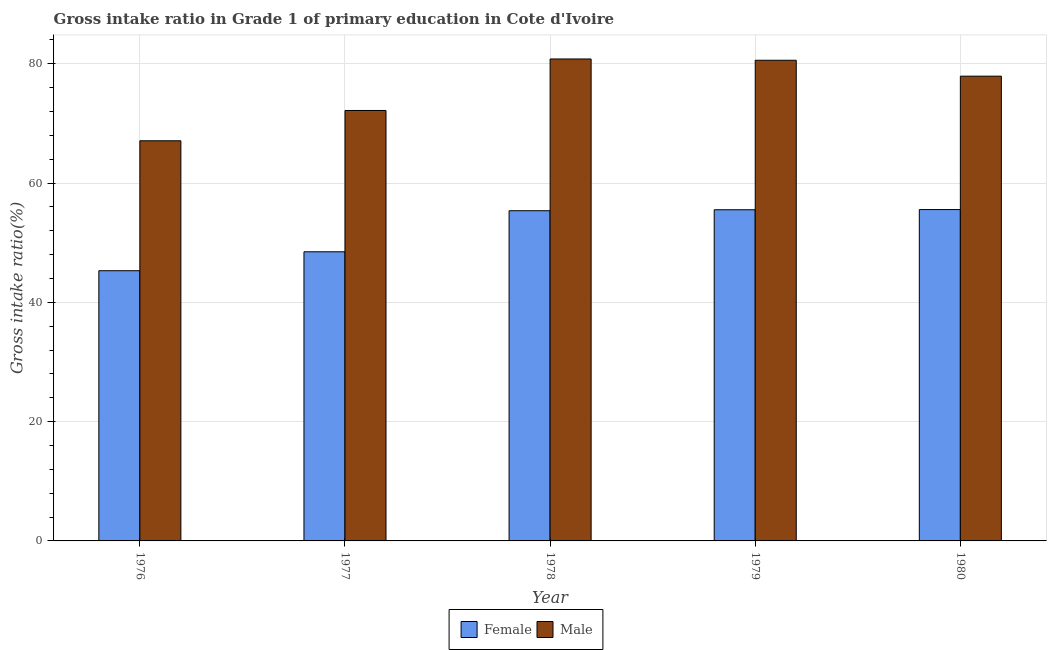Are the number of bars per tick equal to the number of legend labels?
Make the answer very short. Yes. Are the number of bars on each tick of the X-axis equal?
Your response must be concise. Yes. How many bars are there on the 4th tick from the right?
Offer a terse response. 2. What is the label of the 1st group of bars from the left?
Your answer should be very brief. 1976. In how many cases, is the number of bars for a given year not equal to the number of legend labels?
Your answer should be compact. 0. What is the gross intake ratio(male) in 1976?
Your answer should be very brief. 67.09. Across all years, what is the maximum gross intake ratio(female)?
Provide a short and direct response. 55.55. Across all years, what is the minimum gross intake ratio(male)?
Provide a succinct answer. 67.09. In which year was the gross intake ratio(male) maximum?
Your answer should be compact. 1978. In which year was the gross intake ratio(female) minimum?
Your response must be concise. 1976. What is the total gross intake ratio(male) in the graph?
Your answer should be compact. 378.56. What is the difference between the gross intake ratio(male) in 1976 and that in 1979?
Provide a succinct answer. -13.5. What is the difference between the gross intake ratio(female) in 1976 and the gross intake ratio(male) in 1977?
Your response must be concise. -3.17. What is the average gross intake ratio(male) per year?
Offer a terse response. 75.71. In the year 1976, what is the difference between the gross intake ratio(male) and gross intake ratio(female)?
Your response must be concise. 0. In how many years, is the gross intake ratio(female) greater than 36 %?
Give a very brief answer. 5. What is the ratio of the gross intake ratio(female) in 1977 to that in 1978?
Your response must be concise. 0.88. What is the difference between the highest and the second highest gross intake ratio(male)?
Ensure brevity in your answer.  0.21. What is the difference between the highest and the lowest gross intake ratio(female)?
Offer a very short reply. 10.25. In how many years, is the gross intake ratio(male) greater than the average gross intake ratio(male) taken over all years?
Your answer should be very brief. 3. Is the sum of the gross intake ratio(female) in 1976 and 1979 greater than the maximum gross intake ratio(male) across all years?
Offer a terse response. Yes. What does the 2nd bar from the right in 1977 represents?
Give a very brief answer. Female. Are all the bars in the graph horizontal?
Provide a succinct answer. No. How many years are there in the graph?
Provide a short and direct response. 5. What is the difference between two consecutive major ticks on the Y-axis?
Ensure brevity in your answer.  20. Does the graph contain any zero values?
Your response must be concise. No. Does the graph contain grids?
Keep it short and to the point. Yes. How many legend labels are there?
Make the answer very short. 2. How are the legend labels stacked?
Your answer should be very brief. Horizontal. What is the title of the graph?
Make the answer very short. Gross intake ratio in Grade 1 of primary education in Cote d'Ivoire. What is the label or title of the Y-axis?
Give a very brief answer. Gross intake ratio(%). What is the Gross intake ratio(%) in Female in 1976?
Provide a succinct answer. 45.3. What is the Gross intake ratio(%) of Male in 1976?
Provide a short and direct response. 67.09. What is the Gross intake ratio(%) of Female in 1977?
Give a very brief answer. 48.47. What is the Gross intake ratio(%) in Male in 1977?
Give a very brief answer. 72.17. What is the Gross intake ratio(%) of Female in 1978?
Your answer should be compact. 55.36. What is the Gross intake ratio(%) of Male in 1978?
Keep it short and to the point. 80.8. What is the Gross intake ratio(%) of Female in 1979?
Your response must be concise. 55.52. What is the Gross intake ratio(%) in Male in 1979?
Your answer should be compact. 80.59. What is the Gross intake ratio(%) of Female in 1980?
Your response must be concise. 55.55. What is the Gross intake ratio(%) in Male in 1980?
Offer a terse response. 77.92. Across all years, what is the maximum Gross intake ratio(%) of Female?
Provide a short and direct response. 55.55. Across all years, what is the maximum Gross intake ratio(%) of Male?
Your response must be concise. 80.8. Across all years, what is the minimum Gross intake ratio(%) of Female?
Ensure brevity in your answer.  45.3. Across all years, what is the minimum Gross intake ratio(%) in Male?
Provide a succinct answer. 67.09. What is the total Gross intake ratio(%) of Female in the graph?
Keep it short and to the point. 260.21. What is the total Gross intake ratio(%) of Male in the graph?
Provide a short and direct response. 378.56. What is the difference between the Gross intake ratio(%) in Female in 1976 and that in 1977?
Keep it short and to the point. -3.17. What is the difference between the Gross intake ratio(%) in Male in 1976 and that in 1977?
Your response must be concise. -5.08. What is the difference between the Gross intake ratio(%) in Female in 1976 and that in 1978?
Your answer should be compact. -10.06. What is the difference between the Gross intake ratio(%) of Male in 1976 and that in 1978?
Your answer should be very brief. -13.71. What is the difference between the Gross intake ratio(%) in Female in 1976 and that in 1979?
Offer a very short reply. -10.22. What is the difference between the Gross intake ratio(%) in Male in 1976 and that in 1979?
Provide a succinct answer. -13.5. What is the difference between the Gross intake ratio(%) of Female in 1976 and that in 1980?
Your answer should be compact. -10.25. What is the difference between the Gross intake ratio(%) in Male in 1976 and that in 1980?
Provide a succinct answer. -10.83. What is the difference between the Gross intake ratio(%) in Female in 1977 and that in 1978?
Your response must be concise. -6.89. What is the difference between the Gross intake ratio(%) in Male in 1977 and that in 1978?
Make the answer very short. -8.64. What is the difference between the Gross intake ratio(%) in Female in 1977 and that in 1979?
Ensure brevity in your answer.  -7.05. What is the difference between the Gross intake ratio(%) in Male in 1977 and that in 1979?
Your response must be concise. -8.42. What is the difference between the Gross intake ratio(%) of Female in 1977 and that in 1980?
Give a very brief answer. -7.08. What is the difference between the Gross intake ratio(%) in Male in 1977 and that in 1980?
Give a very brief answer. -5.75. What is the difference between the Gross intake ratio(%) of Female in 1978 and that in 1979?
Provide a short and direct response. -0.16. What is the difference between the Gross intake ratio(%) in Male in 1978 and that in 1979?
Offer a terse response. 0.21. What is the difference between the Gross intake ratio(%) in Female in 1978 and that in 1980?
Make the answer very short. -0.19. What is the difference between the Gross intake ratio(%) of Male in 1978 and that in 1980?
Keep it short and to the point. 2.88. What is the difference between the Gross intake ratio(%) in Female in 1979 and that in 1980?
Make the answer very short. -0.03. What is the difference between the Gross intake ratio(%) in Male in 1979 and that in 1980?
Make the answer very short. 2.67. What is the difference between the Gross intake ratio(%) of Female in 1976 and the Gross intake ratio(%) of Male in 1977?
Your answer should be very brief. -26.87. What is the difference between the Gross intake ratio(%) of Female in 1976 and the Gross intake ratio(%) of Male in 1978?
Keep it short and to the point. -35.5. What is the difference between the Gross intake ratio(%) in Female in 1976 and the Gross intake ratio(%) in Male in 1979?
Provide a succinct answer. -35.29. What is the difference between the Gross intake ratio(%) of Female in 1976 and the Gross intake ratio(%) of Male in 1980?
Offer a terse response. -32.62. What is the difference between the Gross intake ratio(%) of Female in 1977 and the Gross intake ratio(%) of Male in 1978?
Offer a very short reply. -32.33. What is the difference between the Gross intake ratio(%) of Female in 1977 and the Gross intake ratio(%) of Male in 1979?
Offer a terse response. -32.11. What is the difference between the Gross intake ratio(%) of Female in 1977 and the Gross intake ratio(%) of Male in 1980?
Ensure brevity in your answer.  -29.45. What is the difference between the Gross intake ratio(%) of Female in 1978 and the Gross intake ratio(%) of Male in 1979?
Offer a very short reply. -25.23. What is the difference between the Gross intake ratio(%) in Female in 1978 and the Gross intake ratio(%) in Male in 1980?
Your answer should be very brief. -22.56. What is the difference between the Gross intake ratio(%) in Female in 1979 and the Gross intake ratio(%) in Male in 1980?
Provide a succinct answer. -22.4. What is the average Gross intake ratio(%) of Female per year?
Your answer should be very brief. 52.04. What is the average Gross intake ratio(%) of Male per year?
Offer a very short reply. 75.71. In the year 1976, what is the difference between the Gross intake ratio(%) of Female and Gross intake ratio(%) of Male?
Keep it short and to the point. -21.79. In the year 1977, what is the difference between the Gross intake ratio(%) of Female and Gross intake ratio(%) of Male?
Provide a short and direct response. -23.69. In the year 1978, what is the difference between the Gross intake ratio(%) of Female and Gross intake ratio(%) of Male?
Offer a terse response. -25.44. In the year 1979, what is the difference between the Gross intake ratio(%) of Female and Gross intake ratio(%) of Male?
Make the answer very short. -25.06. In the year 1980, what is the difference between the Gross intake ratio(%) in Female and Gross intake ratio(%) in Male?
Your answer should be compact. -22.37. What is the ratio of the Gross intake ratio(%) of Female in 1976 to that in 1977?
Provide a succinct answer. 0.93. What is the ratio of the Gross intake ratio(%) of Male in 1976 to that in 1977?
Give a very brief answer. 0.93. What is the ratio of the Gross intake ratio(%) of Female in 1976 to that in 1978?
Your response must be concise. 0.82. What is the ratio of the Gross intake ratio(%) in Male in 1976 to that in 1978?
Your answer should be very brief. 0.83. What is the ratio of the Gross intake ratio(%) in Female in 1976 to that in 1979?
Make the answer very short. 0.82. What is the ratio of the Gross intake ratio(%) in Male in 1976 to that in 1979?
Provide a succinct answer. 0.83. What is the ratio of the Gross intake ratio(%) of Female in 1976 to that in 1980?
Offer a terse response. 0.82. What is the ratio of the Gross intake ratio(%) in Male in 1976 to that in 1980?
Give a very brief answer. 0.86. What is the ratio of the Gross intake ratio(%) in Female in 1977 to that in 1978?
Give a very brief answer. 0.88. What is the ratio of the Gross intake ratio(%) of Male in 1977 to that in 1978?
Give a very brief answer. 0.89. What is the ratio of the Gross intake ratio(%) of Female in 1977 to that in 1979?
Your response must be concise. 0.87. What is the ratio of the Gross intake ratio(%) in Male in 1977 to that in 1979?
Make the answer very short. 0.9. What is the ratio of the Gross intake ratio(%) in Female in 1977 to that in 1980?
Ensure brevity in your answer.  0.87. What is the ratio of the Gross intake ratio(%) of Male in 1977 to that in 1980?
Provide a short and direct response. 0.93. What is the ratio of the Gross intake ratio(%) of Male in 1978 to that in 1979?
Your response must be concise. 1. What is the ratio of the Gross intake ratio(%) in Female in 1978 to that in 1980?
Provide a succinct answer. 1. What is the ratio of the Gross intake ratio(%) of Male in 1978 to that in 1980?
Your answer should be very brief. 1.04. What is the ratio of the Gross intake ratio(%) in Male in 1979 to that in 1980?
Offer a terse response. 1.03. What is the difference between the highest and the second highest Gross intake ratio(%) of Female?
Provide a succinct answer. 0.03. What is the difference between the highest and the second highest Gross intake ratio(%) in Male?
Ensure brevity in your answer.  0.21. What is the difference between the highest and the lowest Gross intake ratio(%) in Female?
Make the answer very short. 10.25. What is the difference between the highest and the lowest Gross intake ratio(%) in Male?
Offer a terse response. 13.71. 